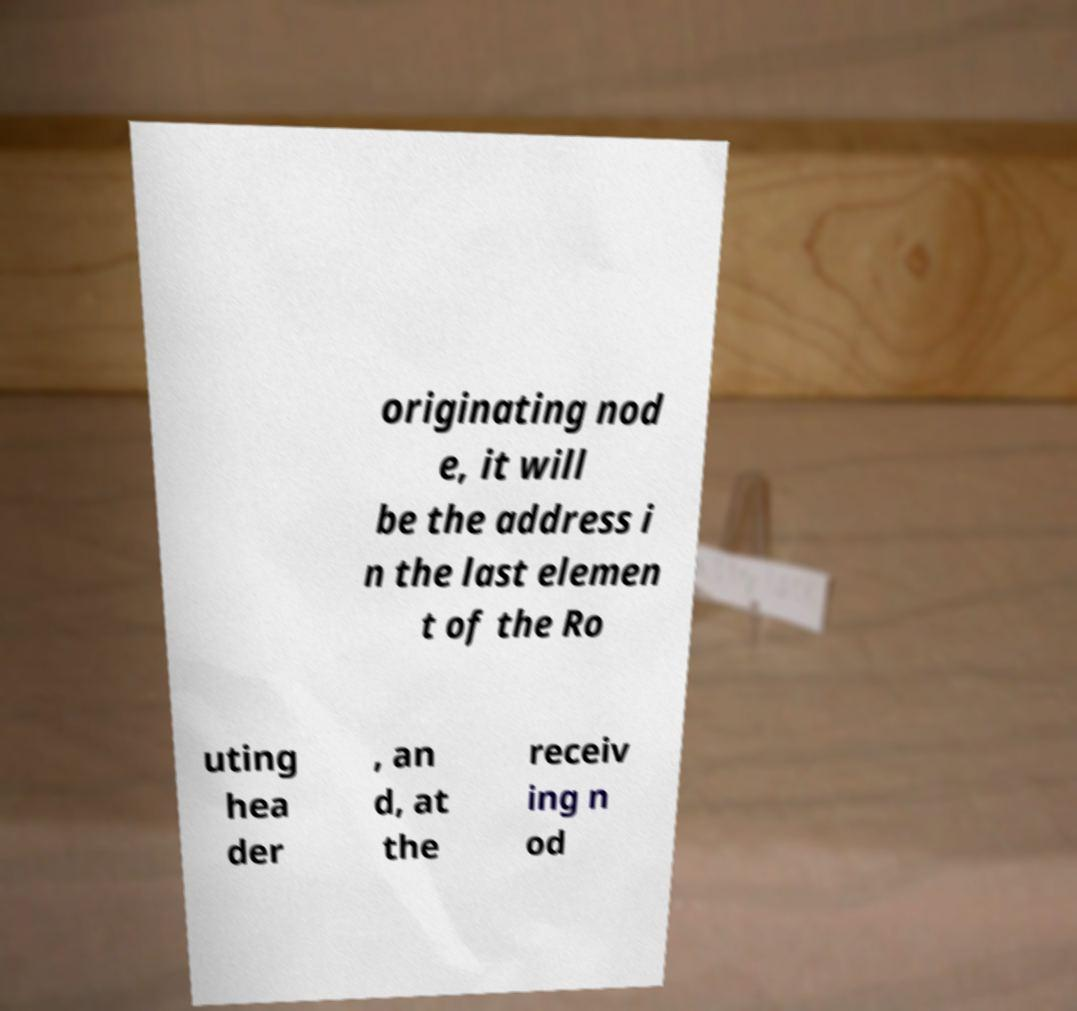Please identify and transcribe the text found in this image. originating nod e, it will be the address i n the last elemen t of the Ro uting hea der , an d, at the receiv ing n od 